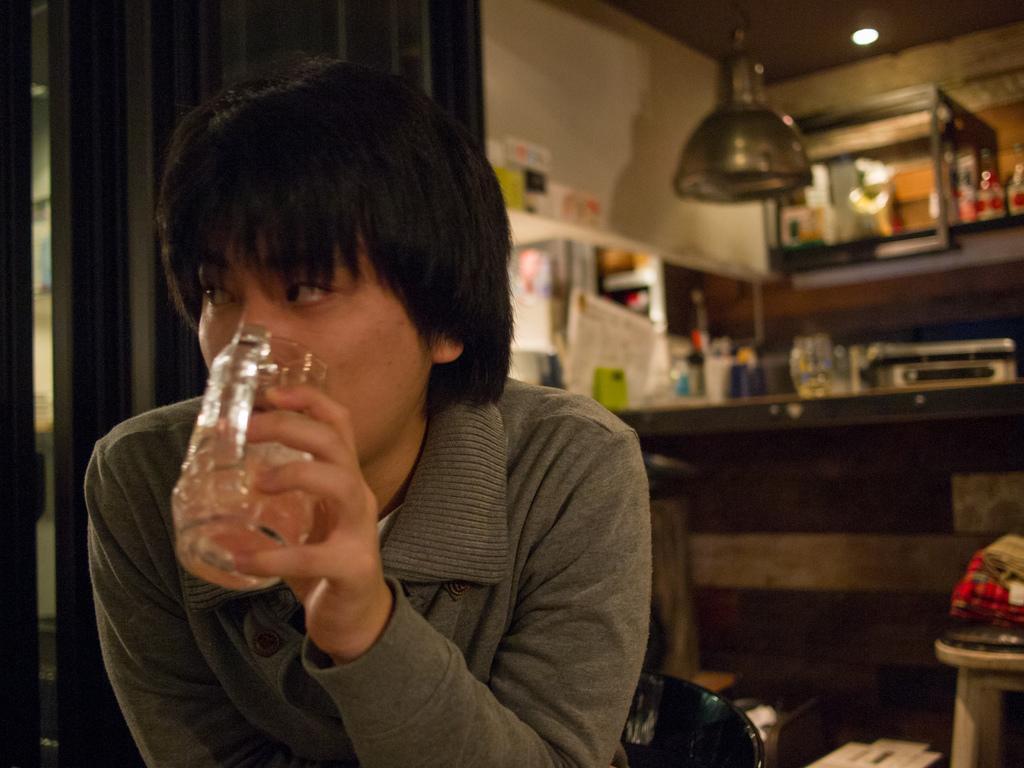How would you summarize this image in a sentence or two? In this image, we can see a person holding an object and in the background, there is a curtain and we can see a light and some other objects and a wall and some posters, a stand and we can see a chair and a stool. At the top, there is a roof. 